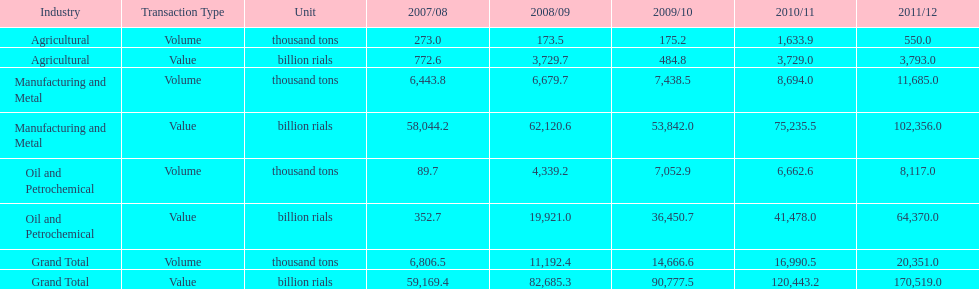What year saw the greatest value for manufacturing and metal in iran? 2011/12. 